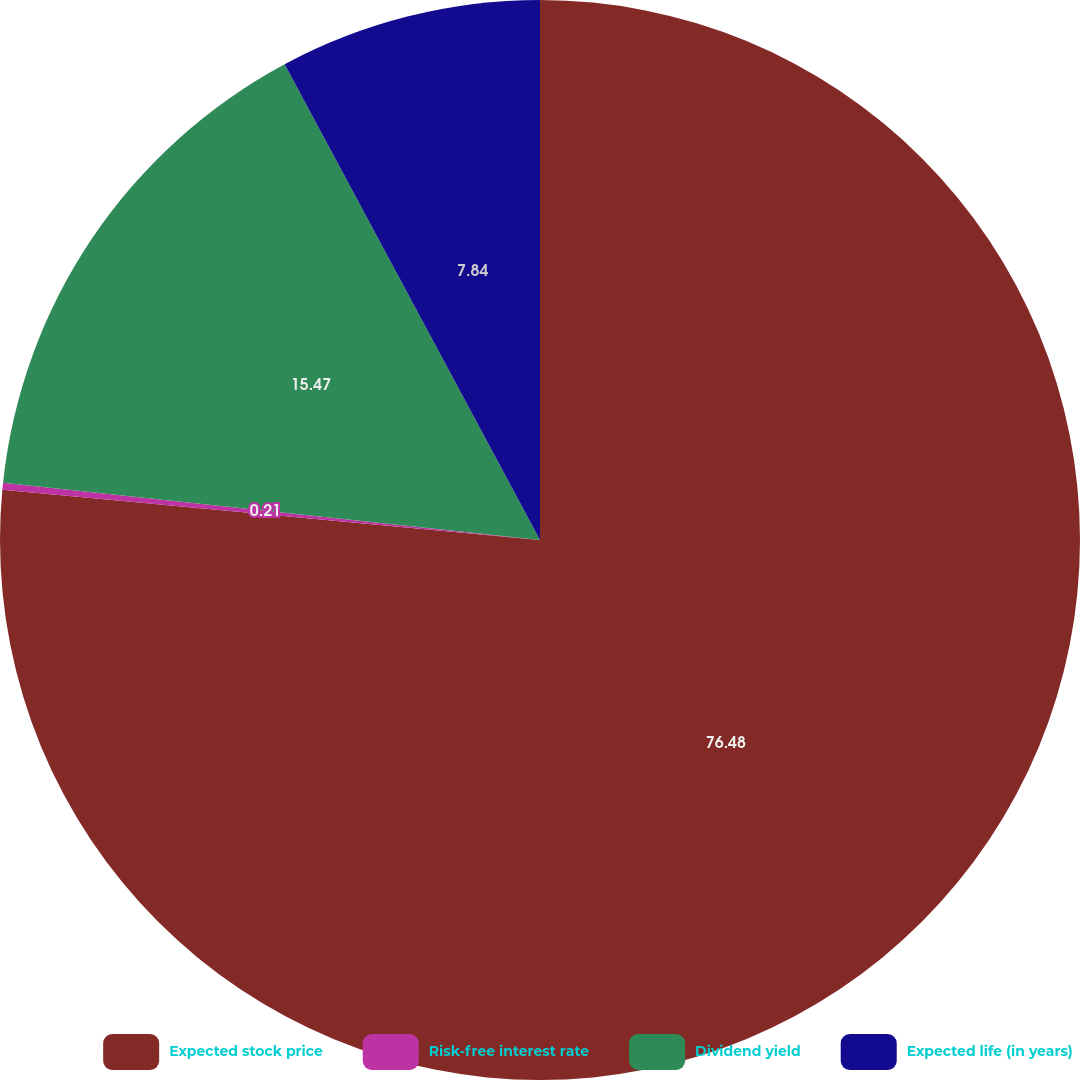Convert chart to OTSL. <chart><loc_0><loc_0><loc_500><loc_500><pie_chart><fcel>Expected stock price<fcel>Risk-free interest rate<fcel>Dividend yield<fcel>Expected life (in years)<nl><fcel>76.48%<fcel>0.21%<fcel>15.47%<fcel>7.84%<nl></chart> 